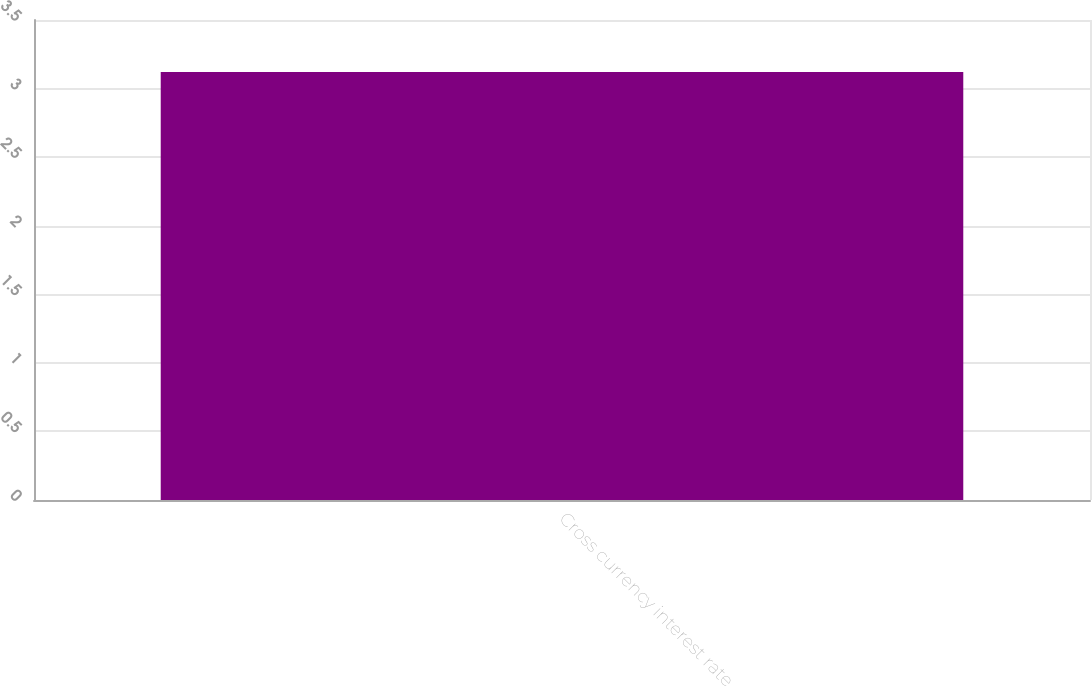Convert chart to OTSL. <chart><loc_0><loc_0><loc_500><loc_500><bar_chart><fcel>Cross currency interest rate<nl><fcel>3.12<nl></chart> 